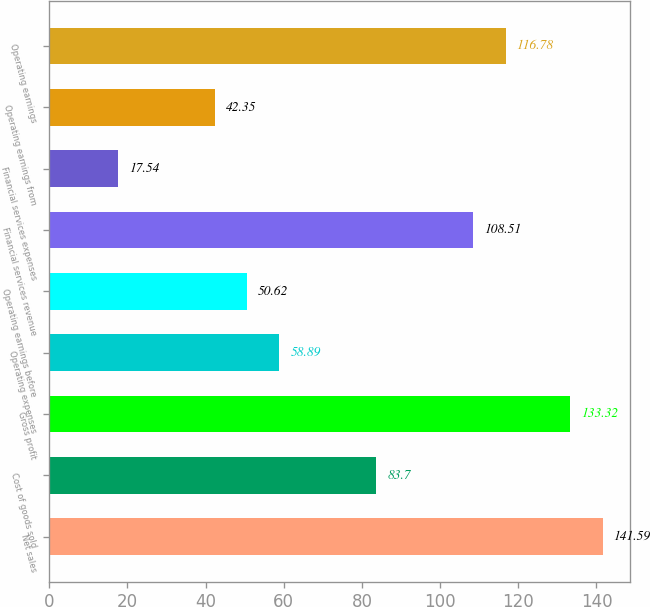Convert chart to OTSL. <chart><loc_0><loc_0><loc_500><loc_500><bar_chart><fcel>Net sales<fcel>Cost of goods sold<fcel>Gross profit<fcel>Operating expenses<fcel>Operating earnings before<fcel>Financial services revenue<fcel>Financial services expenses<fcel>Operating earnings from<fcel>Operating earnings<nl><fcel>141.59<fcel>83.7<fcel>133.32<fcel>58.89<fcel>50.62<fcel>108.51<fcel>17.54<fcel>42.35<fcel>116.78<nl></chart> 